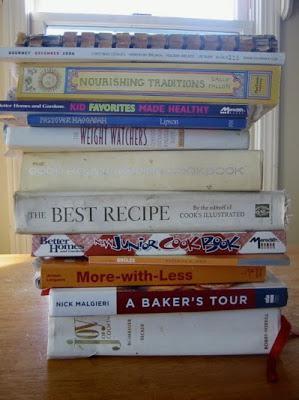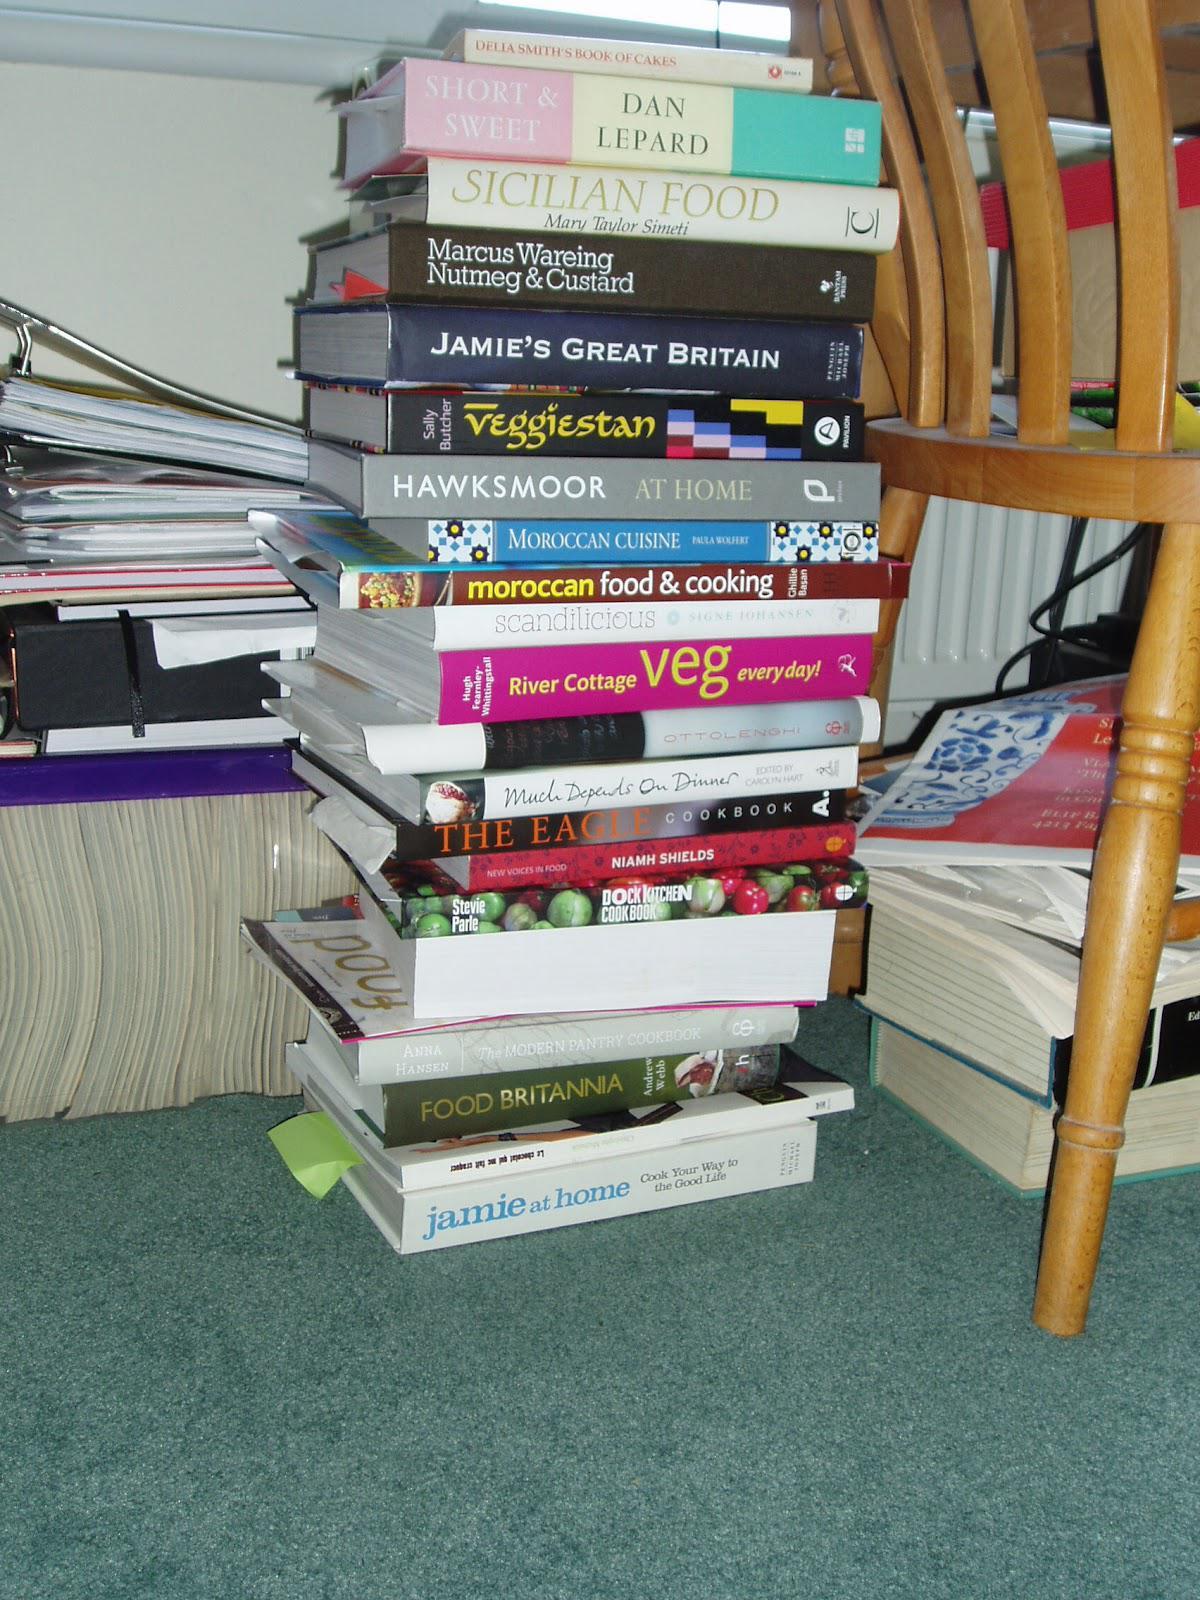The first image is the image on the left, the second image is the image on the right. Given the left and right images, does the statement "In one of the images there are stacks of books not on a shelf." hold true? Answer yes or no. Yes. The first image is the image on the left, the second image is the image on the right. For the images displayed, is the sentence "One image shows binders of various colors arranged vertically on tiered shelves." factually correct? Answer yes or no. No. 